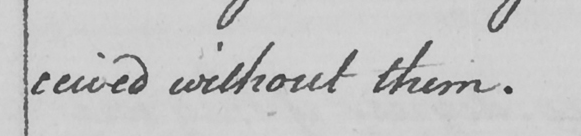What does this handwritten line say? ceived without them . 